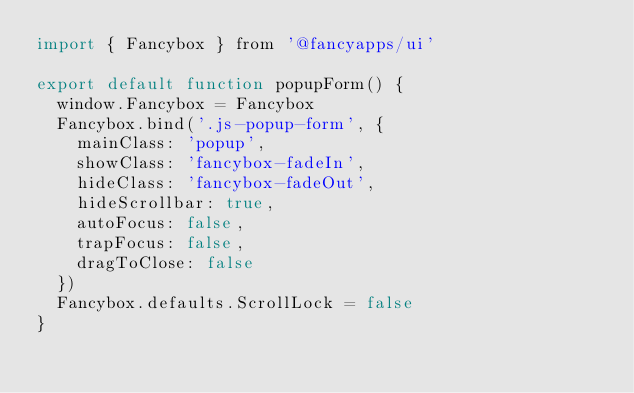Convert code to text. <code><loc_0><loc_0><loc_500><loc_500><_JavaScript_>import { Fancybox } from '@fancyapps/ui'

export default function popupForm() {
  window.Fancybox = Fancybox
  Fancybox.bind('.js-popup-form', {
    mainClass: 'popup',
    showClass: 'fancybox-fadeIn',
    hideClass: 'fancybox-fadeOut',
    hideScrollbar: true,
    autoFocus: false,
    trapFocus: false,
    dragToClose: false
  })
  Fancybox.defaults.ScrollLock = false
}
</code> 